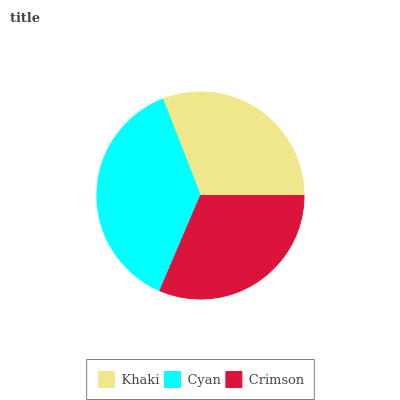Is Khaki the minimum?
Answer yes or no. Yes. Is Cyan the maximum?
Answer yes or no. Yes. Is Crimson the minimum?
Answer yes or no. No. Is Crimson the maximum?
Answer yes or no. No. Is Cyan greater than Crimson?
Answer yes or no. Yes. Is Crimson less than Cyan?
Answer yes or no. Yes. Is Crimson greater than Cyan?
Answer yes or no. No. Is Cyan less than Crimson?
Answer yes or no. No. Is Crimson the high median?
Answer yes or no. Yes. Is Crimson the low median?
Answer yes or no. Yes. Is Khaki the high median?
Answer yes or no. No. Is Khaki the low median?
Answer yes or no. No. 